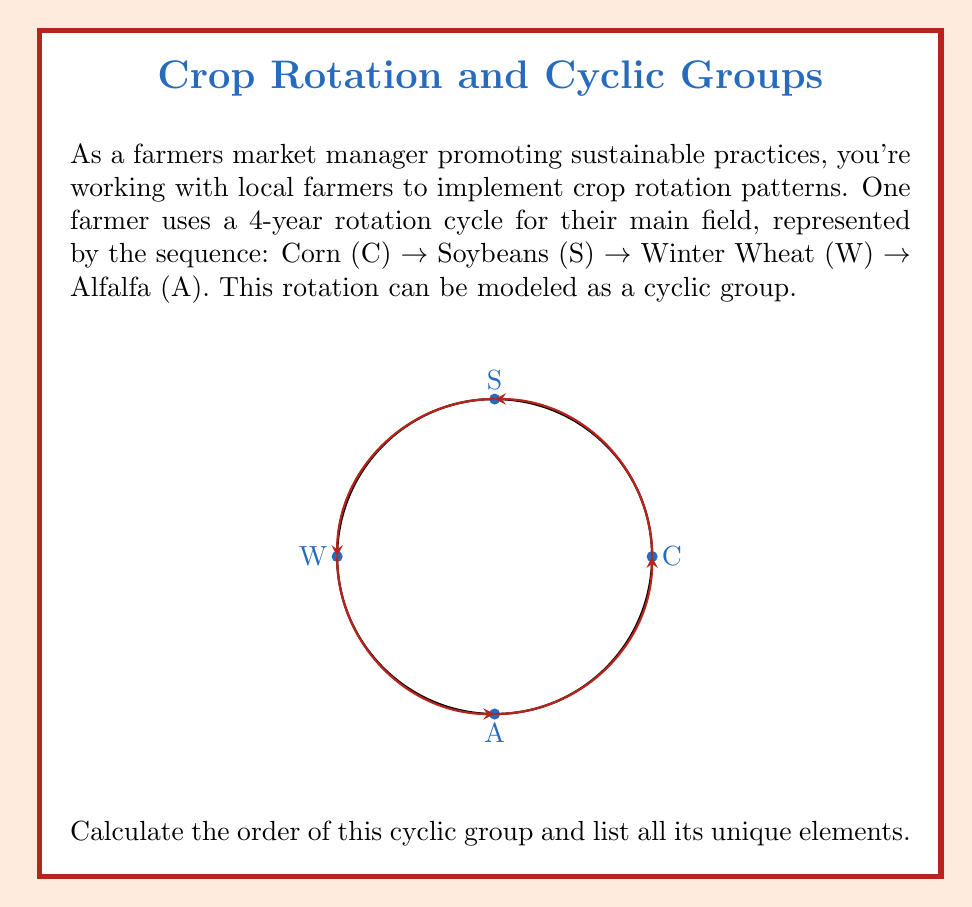Help me with this question. To solve this problem, we'll follow these steps:

1) First, let's understand what a cyclic group is in this context:
   - The crop rotation pattern forms a cyclic group where each rotation is an element of the group.
   - The group operation is the composition of rotations.

2) Identify the generator of the group:
   - The generator is the single-year rotation: C → S → W → A → C
   - Let's call this generator $g$

3) Determine the order of the group:
   - The order of a cyclic group is the smallest positive integer $n$ such that $g^n = e$ (the identity element)
   - In this case, $g^4 = e$ because after 4 rotations, we return to the original state
   - Therefore, the order of the group is 4

4) List all unique elements of the group:
   - $e$: Identity (no rotation)
   - $g$: C → S → W → A → C (one full rotation)
   - $g^2$: C → W → C → S → W (two rotations)
   - $g^3$: C → A → S → W → A (three rotations)

These four elements form the cyclic group $C_4$, which is isomorphic to the group of rotations of a square.
Answer: Order: 4; Elements: $\{e, g, g^2, g^3\}$ 